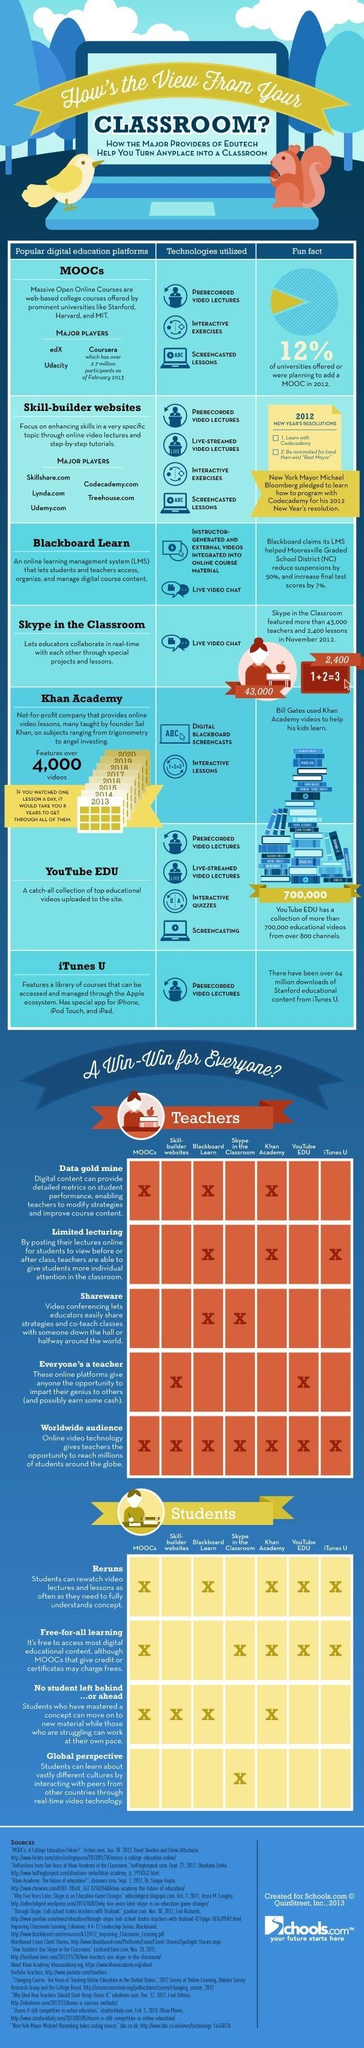List a handful of essential elements in this visual. All digital education platforms provide a universal offering for all teachers and worldwide audiences. The fifth row lists a digital platform called Khan Academy. It is possible for students to watch reruns of their classes on at least 5 different platforms. Khan Academy is a digital platform that provides access to a wealth of data, limited lectures, and a diverse audience. Live video chat technology is widely used by popular digital platforms such as Blackboard Learn and Skype in the Classroom, which have become essential tools for educators and learners alike. 